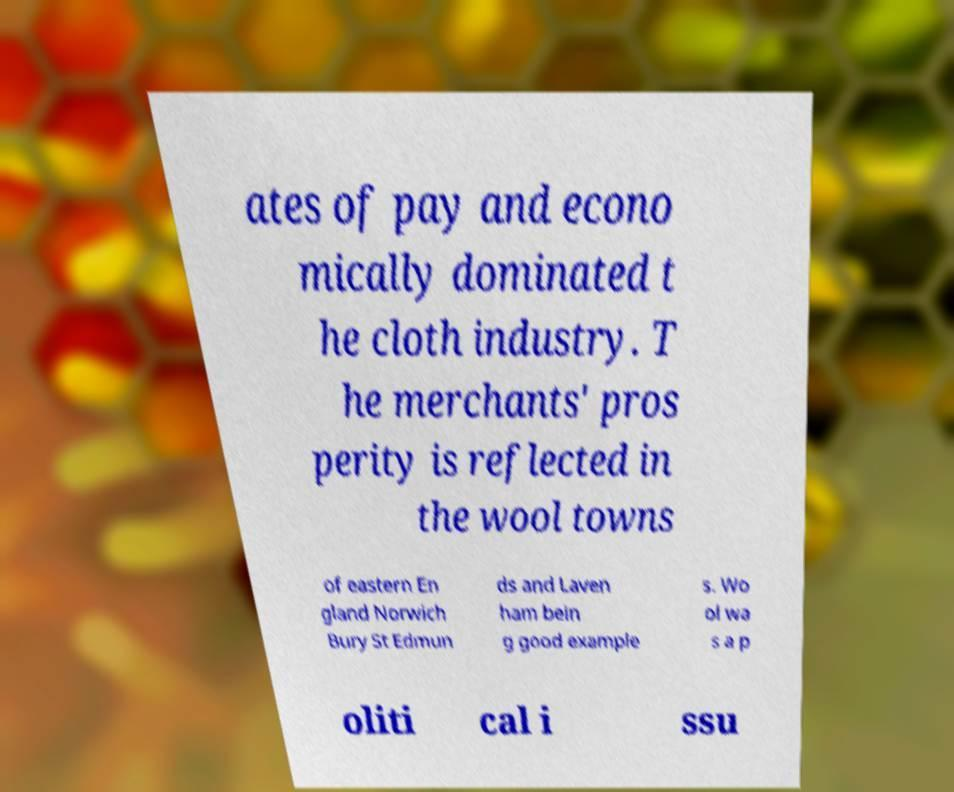What messages or text are displayed in this image? I need them in a readable, typed format. ates of pay and econo mically dominated t he cloth industry. T he merchants' pros perity is reflected in the wool towns of eastern En gland Norwich Bury St Edmun ds and Laven ham bein g good example s. Wo ol wa s a p oliti cal i ssu 